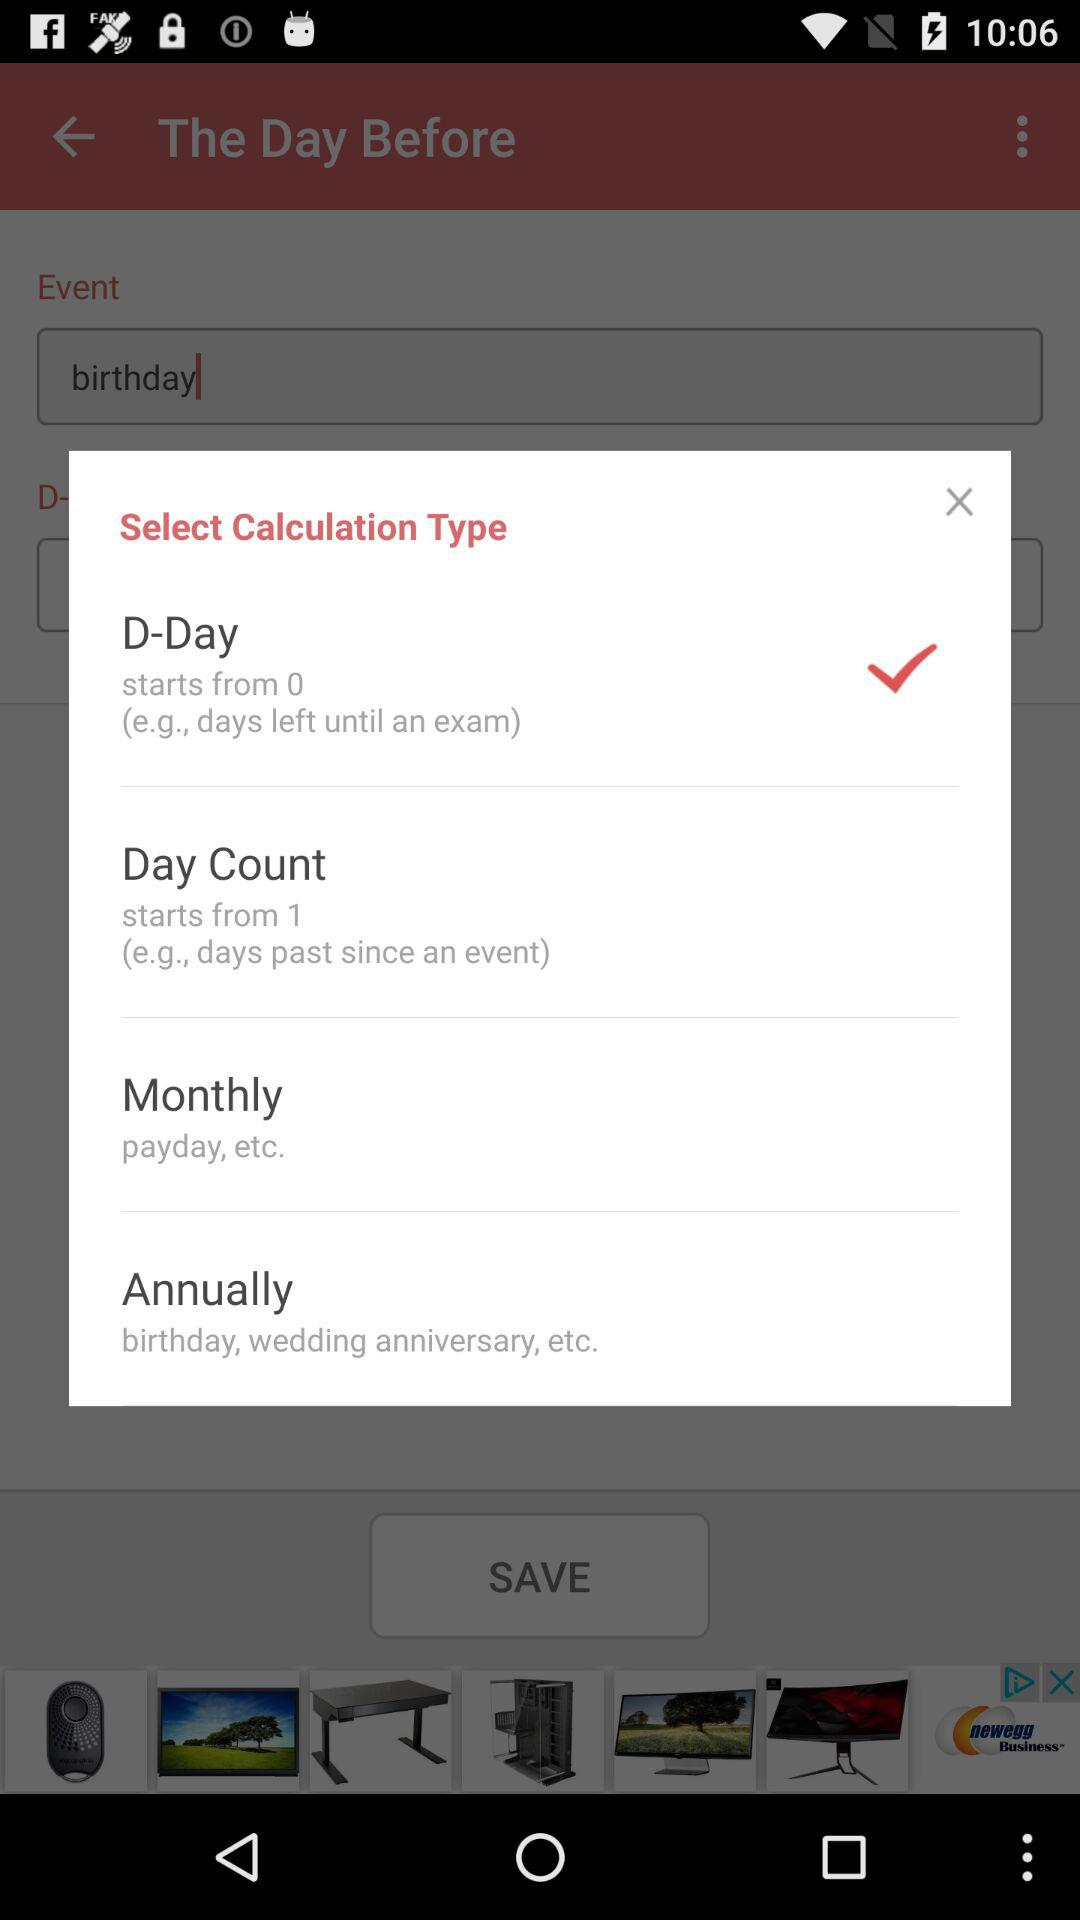How many types of calculations can be done?
Answer the question using a single word or phrase. 4 